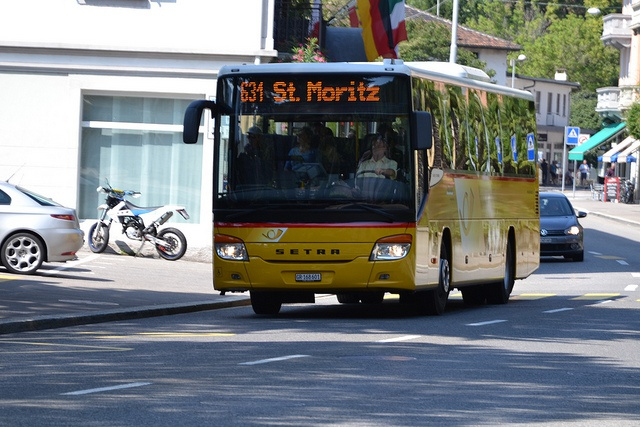Describe the objects in this image and their specific colors. I can see bus in white, black, olive, gray, and darkgray tones, car in white, darkgray, black, and gray tones, motorcycle in white, gray, darkgray, and black tones, car in white, black, blue, and gray tones, and people in white, gray, black, and darkblue tones in this image. 